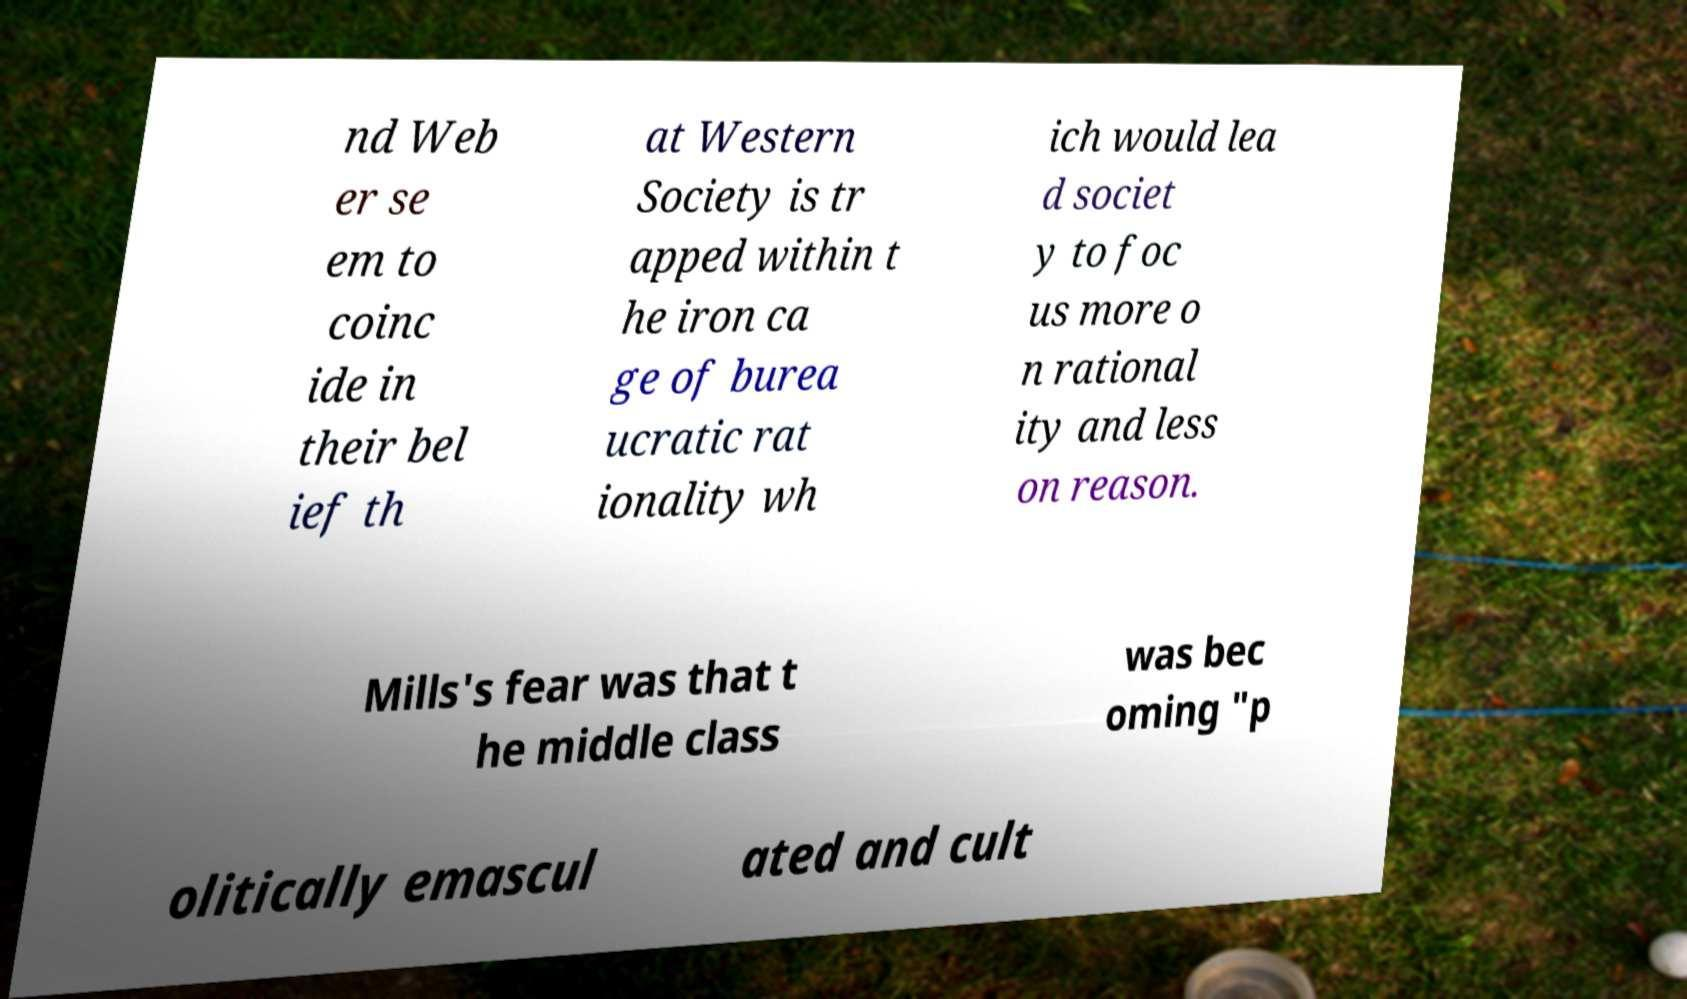Could you assist in decoding the text presented in this image and type it out clearly? nd Web er se em to coinc ide in their bel ief th at Western Society is tr apped within t he iron ca ge of burea ucratic rat ionality wh ich would lea d societ y to foc us more o n rational ity and less on reason. Mills's fear was that t he middle class was bec oming "p olitically emascul ated and cult 